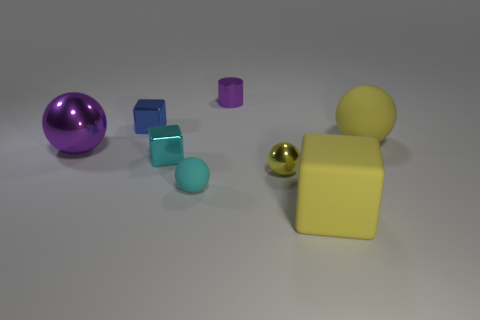How many small cyan cylinders are there?
Keep it short and to the point. 0. Is there any other thing that is made of the same material as the small purple cylinder?
Your answer should be compact. Yes. There is a large object that is the same shape as the small cyan metallic thing; what is its material?
Provide a short and direct response. Rubber. Is the number of cyan spheres that are in front of the cyan rubber object less than the number of green metal balls?
Your answer should be compact. No. Do the large matte thing in front of the small cyan rubber object and the small matte thing have the same shape?
Your answer should be very brief. No. Are there any other things that have the same color as the small rubber ball?
Ensure brevity in your answer.  Yes. What size is the cyan thing that is made of the same material as the purple cylinder?
Ensure brevity in your answer.  Small. What material is the big sphere that is in front of the yellow ball that is behind the small metallic block that is on the right side of the small blue metal cube?
Provide a short and direct response. Metal. Is the number of small shiny things less than the number of yellow rubber things?
Make the answer very short. No. Do the cyan block and the tiny purple cylinder have the same material?
Your response must be concise. Yes. 